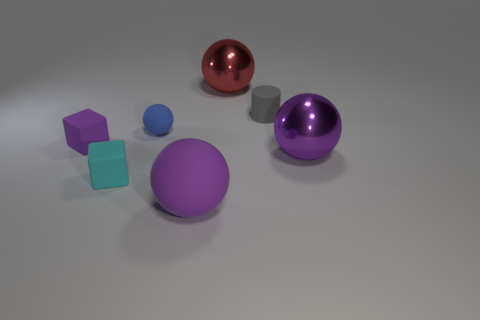What shape is the other big thing that is made of the same material as the cyan thing?
Keep it short and to the point. Sphere. There is a large metal object to the right of the tiny gray matte cylinder; is its shape the same as the red object?
Offer a very short reply. Yes. There is a matte object that is behind the rubber sphere behind the cyan rubber thing; how big is it?
Make the answer very short. Small. What is the color of the other large sphere that is made of the same material as the blue ball?
Provide a succinct answer. Purple. What number of red spheres are the same size as the purple matte cube?
Ensure brevity in your answer.  0. What number of green things are either large metal cylinders or tiny rubber spheres?
Provide a succinct answer. 0. What number of things are either large rubber spheres or small purple blocks behind the large purple rubber sphere?
Offer a terse response. 2. There is a tiny cyan cube behind the big purple matte thing; what is its material?
Offer a very short reply. Rubber. What is the shape of the purple rubber thing that is the same size as the blue matte object?
Your response must be concise. Cube. Are there any other big purple shiny objects of the same shape as the big purple metal object?
Make the answer very short. No. 